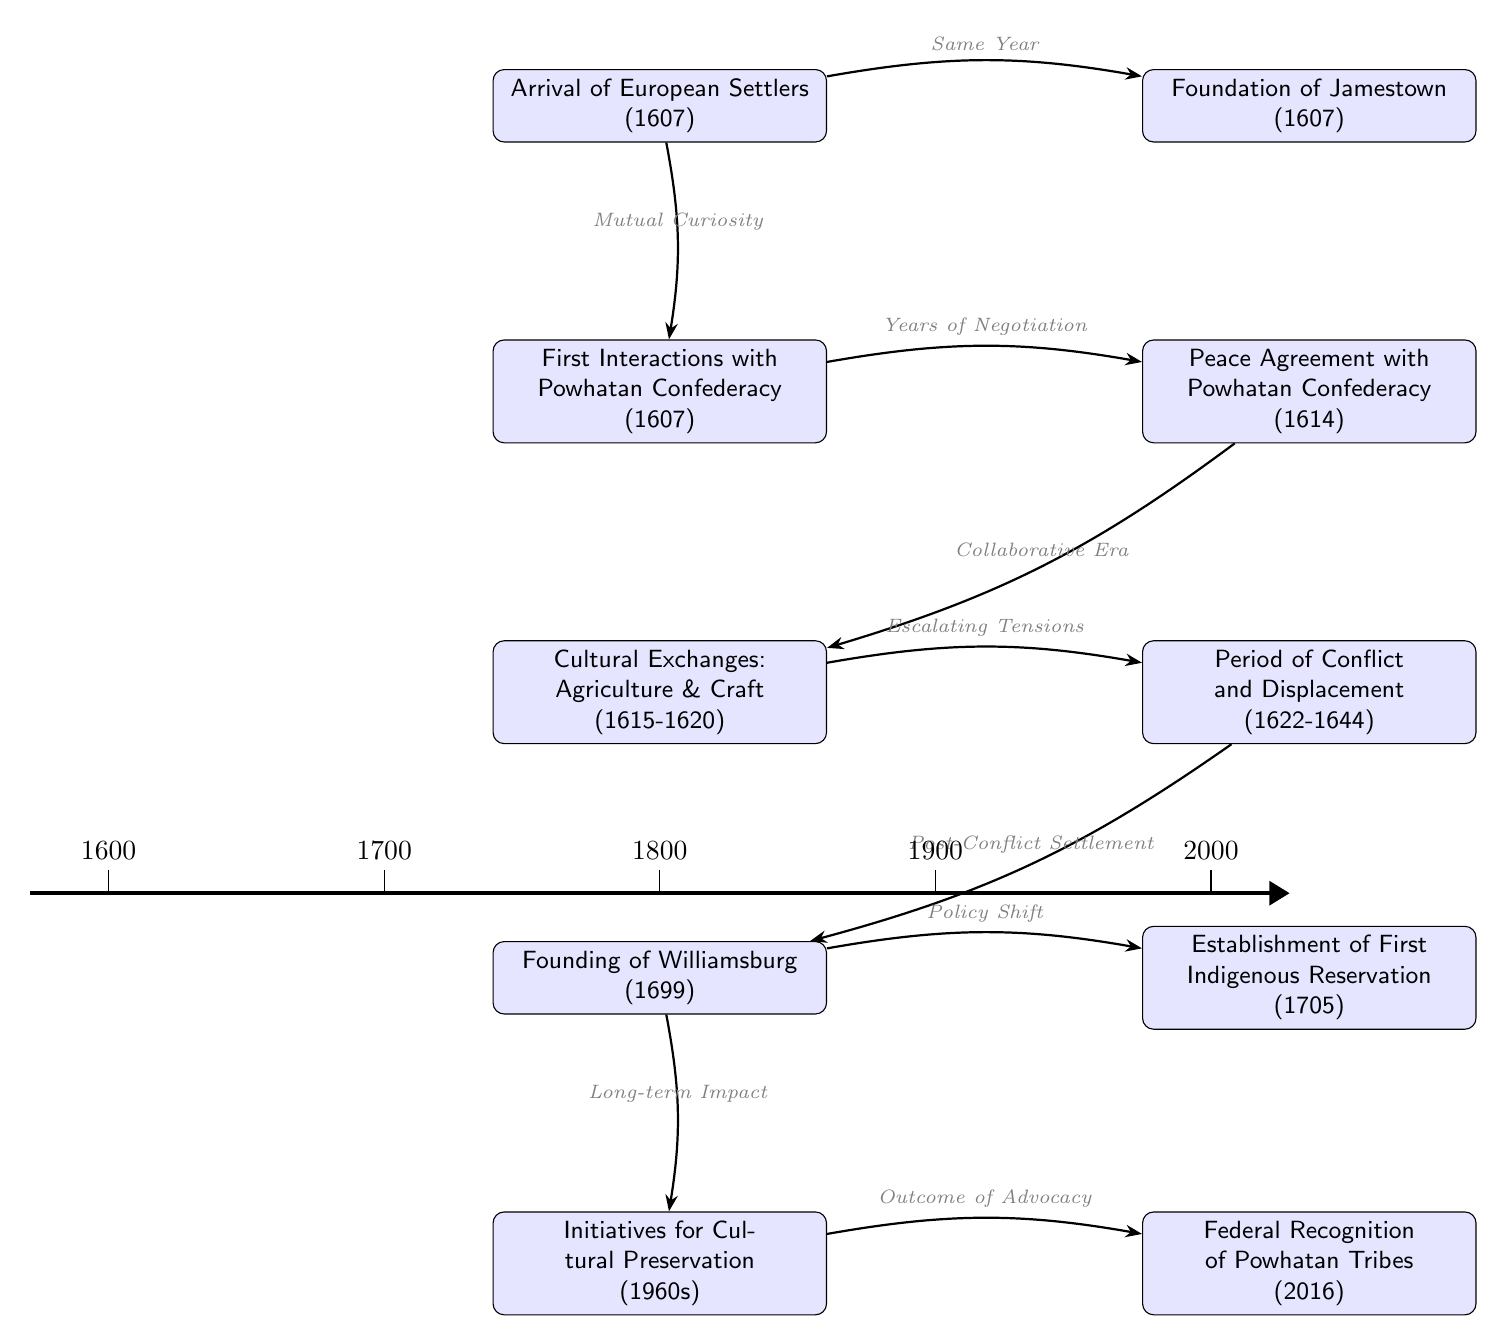What year did the first interactions with the Powhatan Confederacy occur? According to the diagram, the first interactions occurred in the year 1607, which is directly stated in the node for "First Interactions with Powhatan Confederacy."
Answer: 1607 What event is related to the founding of Williamsburg? The diagram indicates that the "Founding of Williamsburg" (1699) is directly connected to the "Period of Conflict and Displacement," showing that it was a post-conflict settlement that followed this challenging period.
Answer: Period of Conflict and Displacement How many major historical events are represented in the diagram? By counting the nodes in the diagram, there are a total of 10 major historical events listed, including events from the arrival of settlers to federal recognition of tribes.
Answer: 10 What was the relationship between the peace agreement and the cultural exchanges? The diagram shows an arrow going from "Peace Agreement with Powhatan Confederacy" to "Cultural Exchanges: Agriculture & Craft," indicating that these exchanges were part of the resulting collaborative era after the peace agreement.
Answer: Collaborative Era What type of milestone is indicated by the establishment of the first Indigenous reservation? The diagram classifies the "Establishment of First Indigenous Reservation" as a key cultural milestone, occurring in 1705, showing a significant change in policy and interaction with Indigenous tribes.
Answer: Key Cultural Milestone What event is the outcome of advocacy according to the diagram? According to the diagram, "Federal Recognition of Powhatan Tribes" in 2016 is indicated as the outcome of advocacy efforts, which came after initiatives for cultural preservation in the 1960s.
Answer: Federal Recognition of Powhatan Tribes What does the arrow from "Cultural Exchanges" to "Period of Conflict and Displacement" indicate? The arrow from "Cultural Exchanges: Agriculture & Craft" to "Period of Conflict and Displacement" illustrates a progression that indicates that escalating tensions followed the initial cultural exchanges, leading to conflict and displacement of the Indigenous community.
Answer: Escalating Tensions What year marks the initiatives for cultural preservation? The diagram states that initiatives for cultural preservation occurred in the 1960s, which is specifically mentioned in the corresponding event node.
Answer: 1960s 